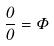Convert formula to latex. <formula><loc_0><loc_0><loc_500><loc_500>\frac { 0 } { 0 } = \Phi</formula> 